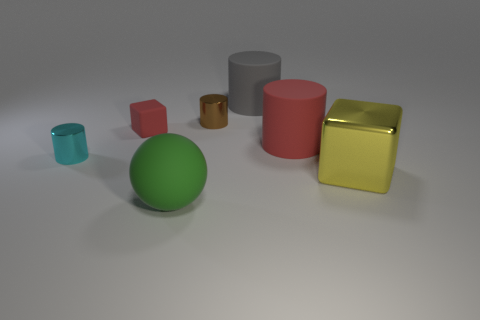Subtract all blue cylinders. Subtract all purple blocks. How many cylinders are left? 4 Add 1 small cylinders. How many objects exist? 8 Subtract all blocks. How many objects are left? 5 Subtract all tiny cubes. Subtract all blocks. How many objects are left? 4 Add 2 metal cylinders. How many metal cylinders are left? 4 Add 2 small red rubber blocks. How many small red rubber blocks exist? 3 Subtract 1 brown cylinders. How many objects are left? 6 